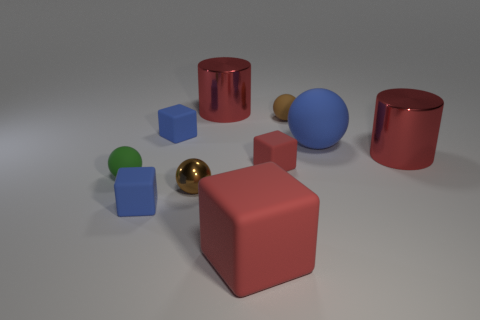How many brown objects have the same material as the large block?
Ensure brevity in your answer.  1. What material is the red object that is on the right side of the small red rubber block?
Offer a terse response. Metal. There is a large metal thing that is on the left side of the large red metallic cylinder on the right side of the metal thing behind the big blue rubber ball; what shape is it?
Offer a very short reply. Cylinder. There is a metal cylinder that is left of the big rubber block; is its color the same as the small cube on the right side of the tiny shiny ball?
Give a very brief answer. Yes. Are there fewer green things behind the tiny red rubber block than blocks in front of the green thing?
Provide a succinct answer. Yes. The other metal object that is the same shape as the big blue object is what color?
Make the answer very short. Brown. There is a tiny brown metal object; is its shape the same as the small brown thing behind the brown metallic sphere?
Ensure brevity in your answer.  Yes. What number of objects are either rubber balls to the left of the big blue thing or blocks that are on the left side of the small shiny ball?
Offer a terse response. 4. What number of other things are there of the same size as the brown metallic object?
Your answer should be very brief. 5. How big is the blue matte object to the right of the brown shiny sphere?
Your answer should be compact. Large. 